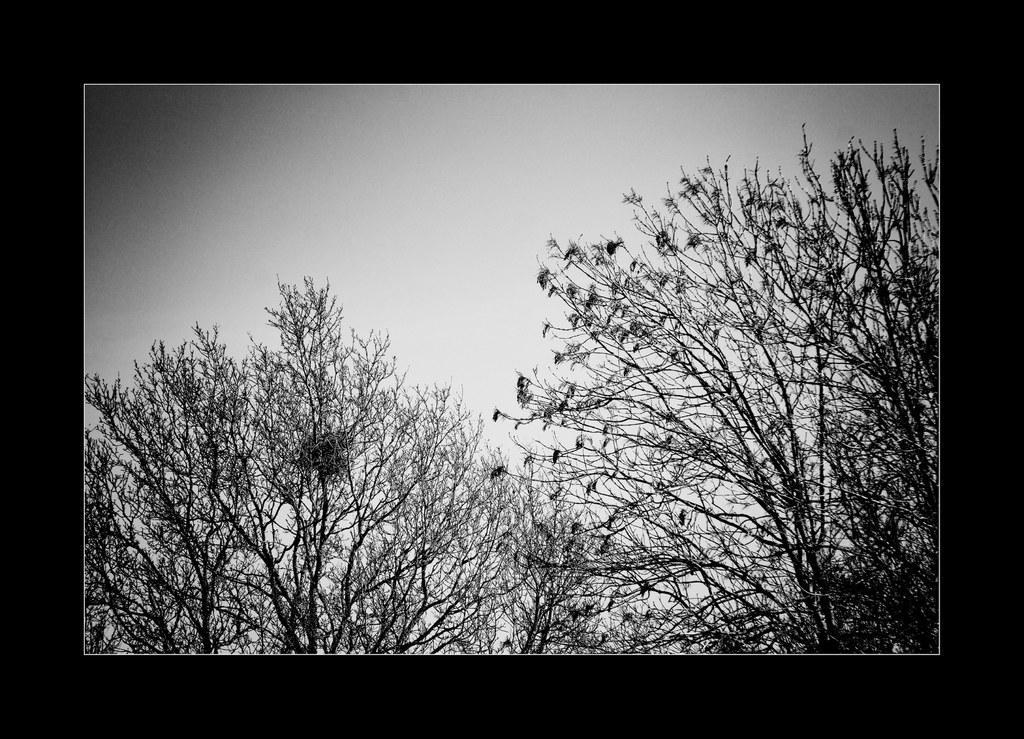Describe this image in one or two sentences. In this picture there is a black and white photograph of the dry trees, seen in the image. 